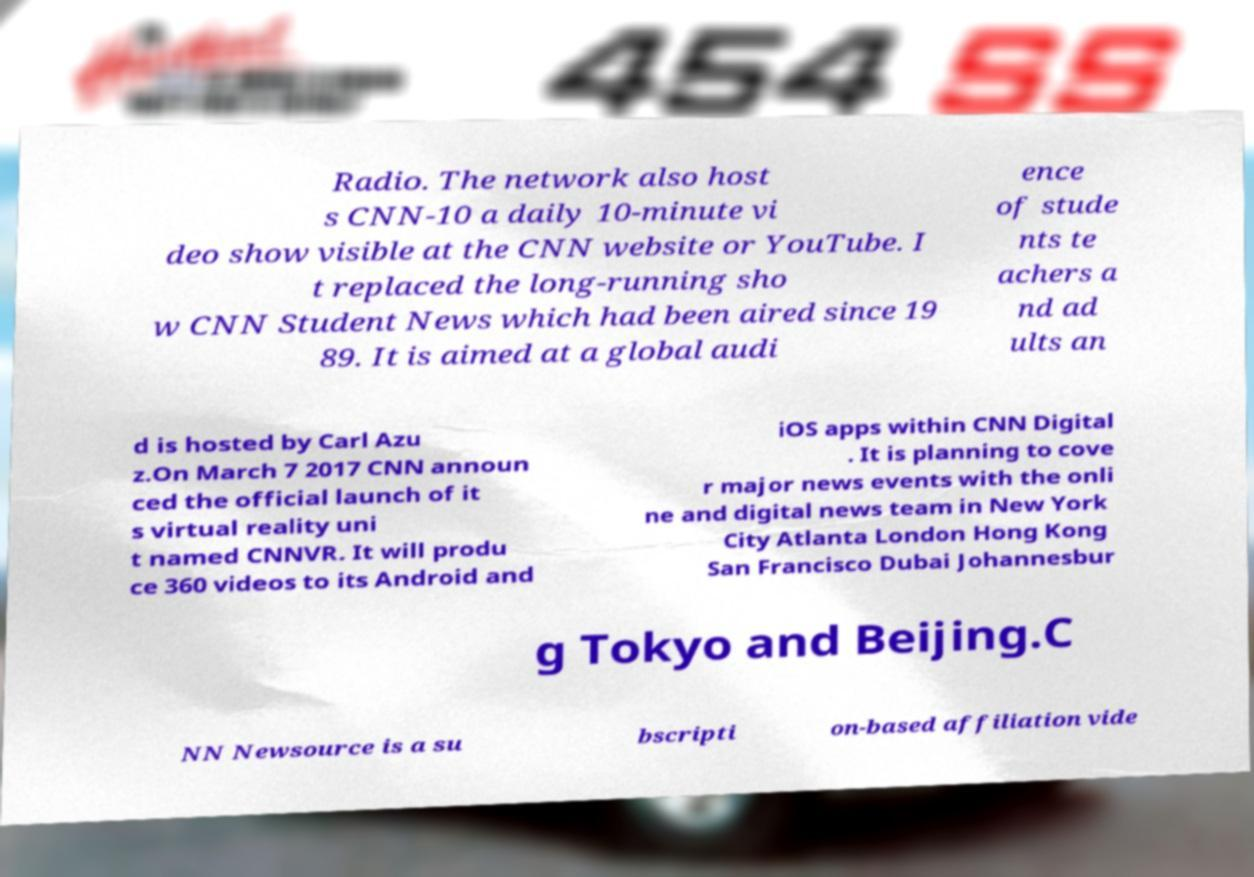There's text embedded in this image that I need extracted. Can you transcribe it verbatim? Radio. The network also host s CNN-10 a daily 10-minute vi deo show visible at the CNN website or YouTube. I t replaced the long-running sho w CNN Student News which had been aired since 19 89. It is aimed at a global audi ence of stude nts te achers a nd ad ults an d is hosted by Carl Azu z.On March 7 2017 CNN announ ced the official launch of it s virtual reality uni t named CNNVR. It will produ ce 360 videos to its Android and iOS apps within CNN Digital . It is planning to cove r major news events with the onli ne and digital news team in New York City Atlanta London Hong Kong San Francisco Dubai Johannesbur g Tokyo and Beijing.C NN Newsource is a su bscripti on-based affiliation vide 